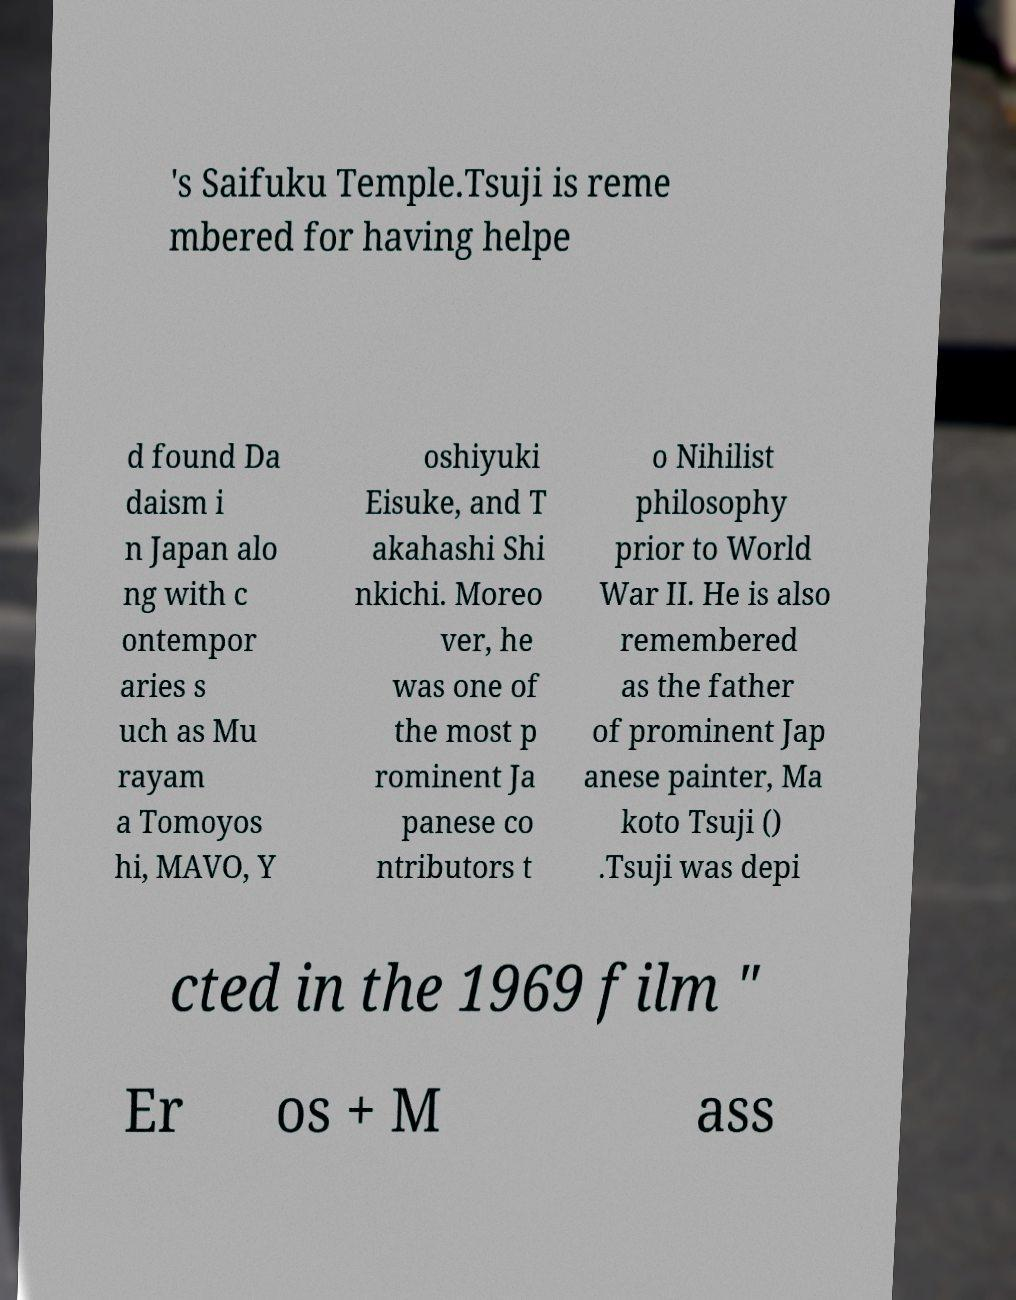For documentation purposes, I need the text within this image transcribed. Could you provide that? 's Saifuku Temple.Tsuji is reme mbered for having helpe d found Da daism i n Japan alo ng with c ontempor aries s uch as Mu rayam a Tomoyos hi, MAVO, Y oshiyuki Eisuke, and T akahashi Shi nkichi. Moreo ver, he was one of the most p rominent Ja panese co ntributors t o Nihilist philosophy prior to World War II. He is also remembered as the father of prominent Jap anese painter, Ma koto Tsuji () .Tsuji was depi cted in the 1969 film " Er os + M ass 